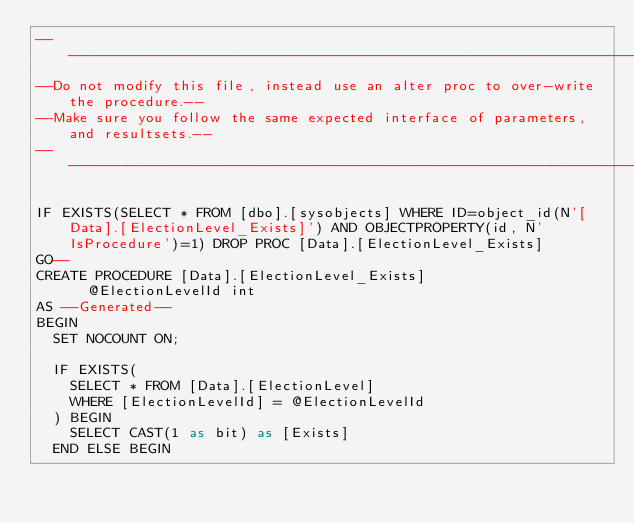Convert code to text. <code><loc_0><loc_0><loc_500><loc_500><_SQL_>-----------------------------------------------------------------------------------
--Do not modify this file, instead use an alter proc to over-write the procedure.--
--Make sure you follow the same expected interface of parameters, and resultsets.--
-----------------------------------------------------------------------------------

IF EXISTS(SELECT * FROM [dbo].[sysobjects] WHERE ID=object_id(N'[Data].[ElectionLevel_Exists]') AND OBJECTPROPERTY(id, N'IsProcedure')=1) DROP PROC [Data].[ElectionLevel_Exists]
GO--
CREATE PROCEDURE [Data].[ElectionLevel_Exists]
			@ElectionLevelId int
AS --Generated--
BEGIN
	SET NOCOUNT ON;

	IF EXISTS(
		SELECT * FROM [Data].[ElectionLevel]
		WHERE	[ElectionLevelId] = @ElectionLevelId
	) BEGIN
		SELECT CAST(1 as bit) as [Exists]
	END ELSE BEGIN</code> 